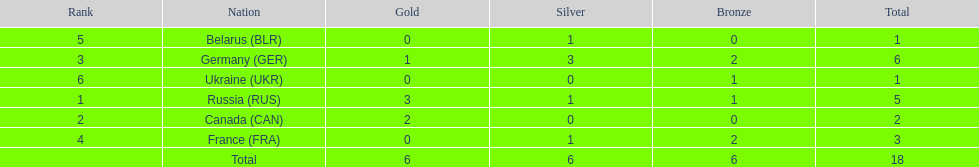What country had the most medals total at the the 1994 winter olympics biathlon? Germany (GER). 